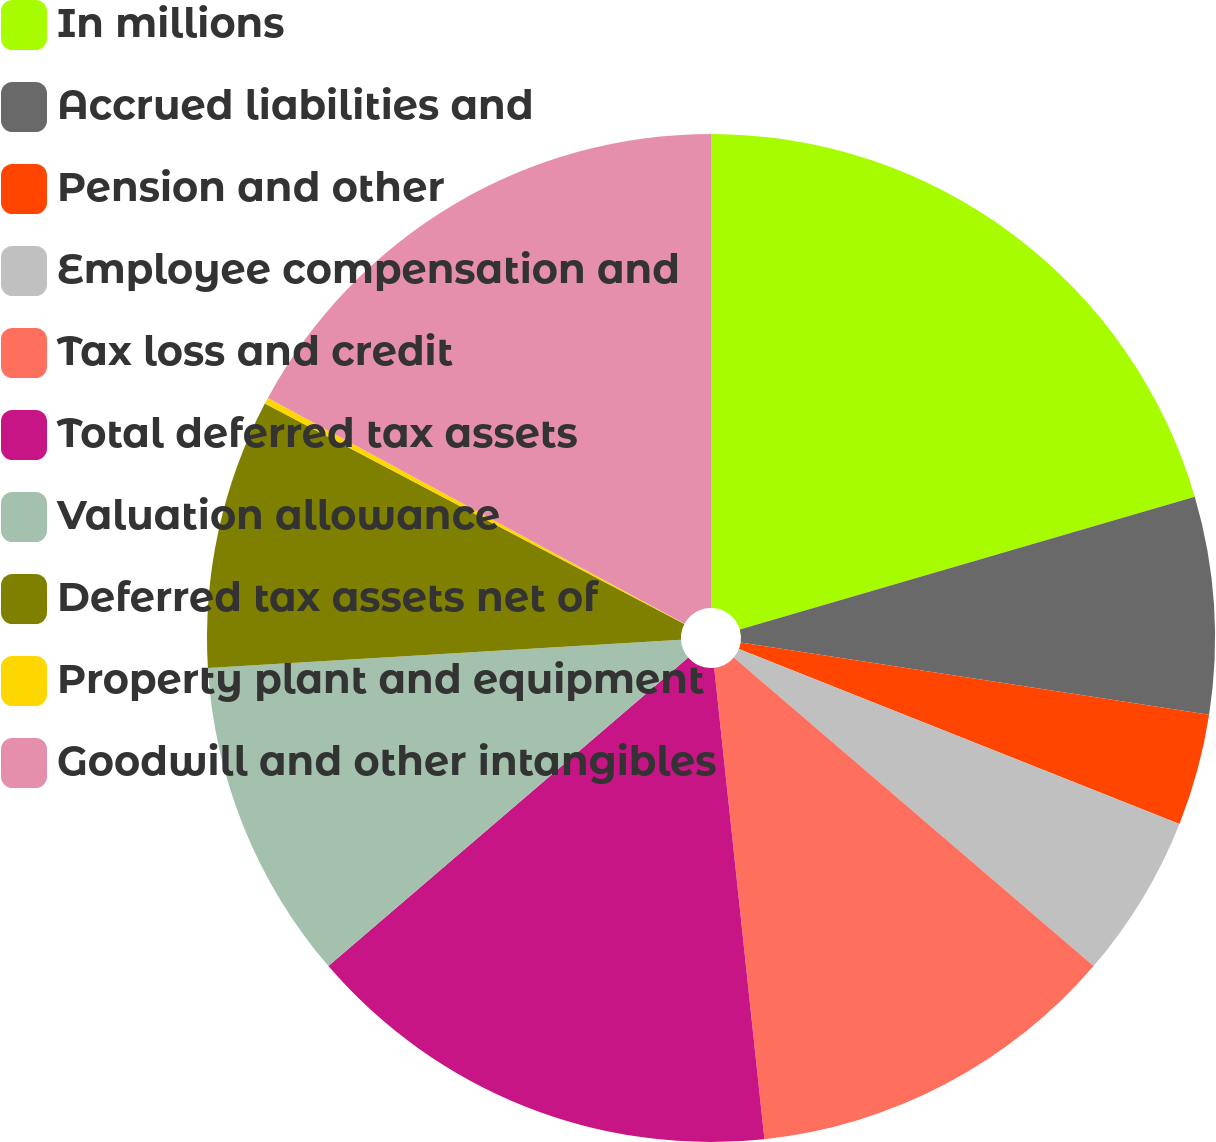Convert chart to OTSL. <chart><loc_0><loc_0><loc_500><loc_500><pie_chart><fcel>In millions<fcel>Accrued liabilities and<fcel>Pension and other<fcel>Employee compensation and<fcel>Tax loss and credit<fcel>Total deferred tax assets<fcel>Valuation allowance<fcel>Deferred tax assets net of<fcel>Property plant and equipment<fcel>Goodwill and other intangibles<nl><fcel>20.48%<fcel>6.96%<fcel>3.58%<fcel>5.27%<fcel>12.03%<fcel>15.41%<fcel>10.34%<fcel>8.65%<fcel>0.2%<fcel>17.1%<nl></chart> 